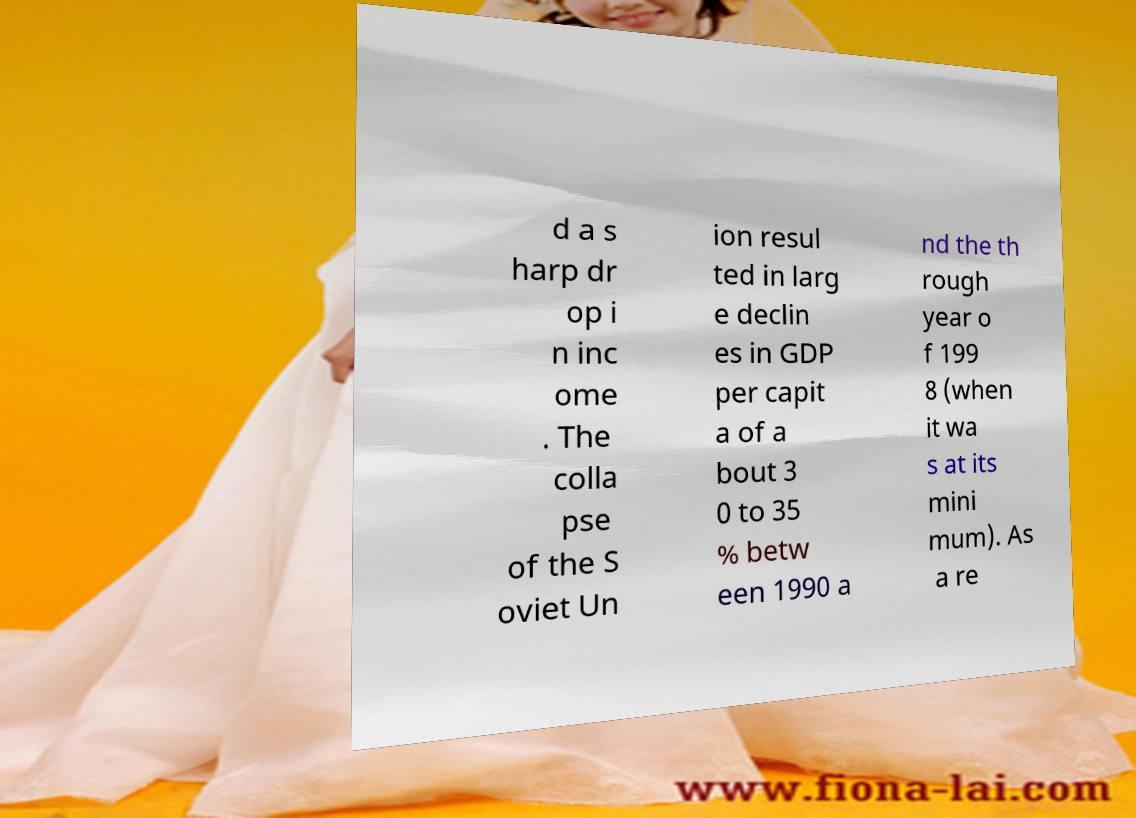Please identify and transcribe the text found in this image. d a s harp dr op i n inc ome . The colla pse of the S oviet Un ion resul ted in larg e declin es in GDP per capit a of a bout 3 0 to 35 % betw een 1990 a nd the th rough year o f 199 8 (when it wa s at its mini mum). As a re 